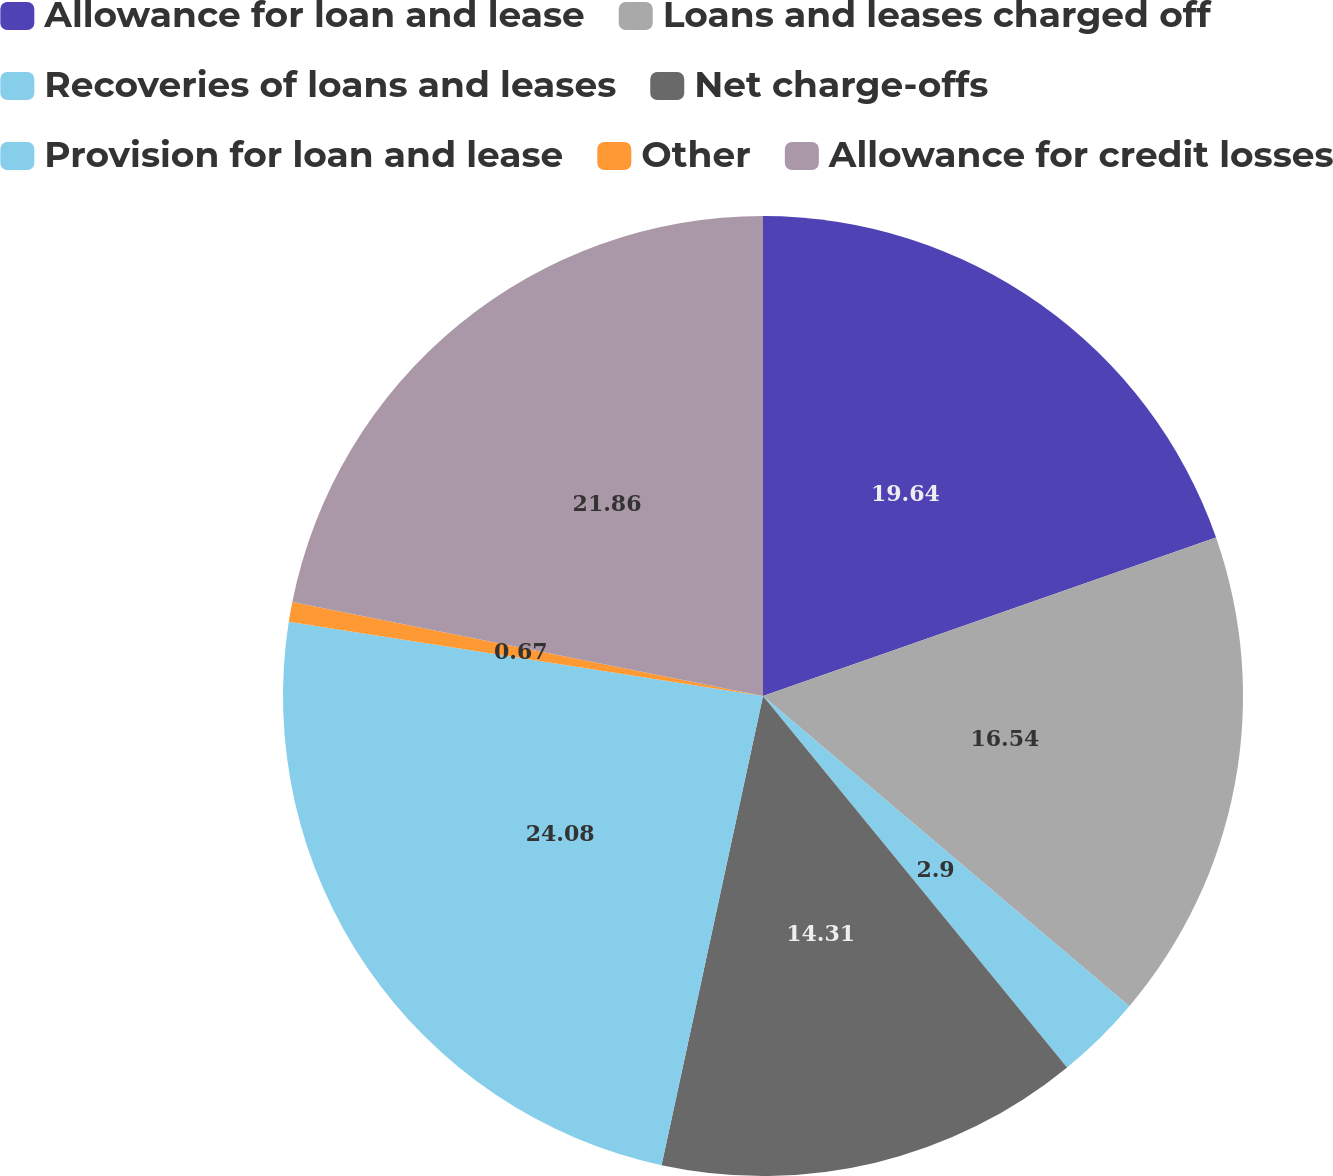Convert chart to OTSL. <chart><loc_0><loc_0><loc_500><loc_500><pie_chart><fcel>Allowance for loan and lease<fcel>Loans and leases charged off<fcel>Recoveries of loans and leases<fcel>Net charge-offs<fcel>Provision for loan and lease<fcel>Other<fcel>Allowance for credit losses<nl><fcel>19.64%<fcel>16.54%<fcel>2.9%<fcel>14.31%<fcel>24.08%<fcel>0.67%<fcel>21.86%<nl></chart> 